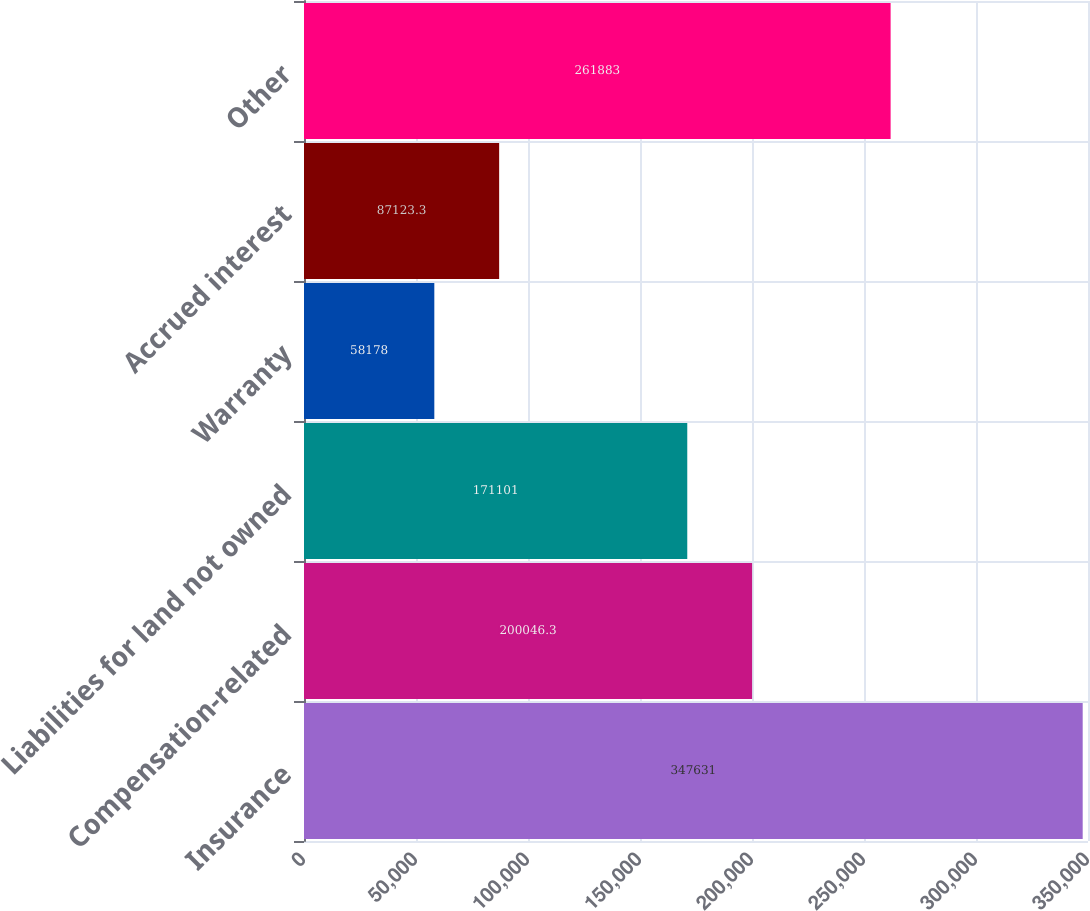Convert chart. <chart><loc_0><loc_0><loc_500><loc_500><bar_chart><fcel>Insurance<fcel>Compensation-related<fcel>Liabilities for land not owned<fcel>Warranty<fcel>Accrued interest<fcel>Other<nl><fcel>347631<fcel>200046<fcel>171101<fcel>58178<fcel>87123.3<fcel>261883<nl></chart> 